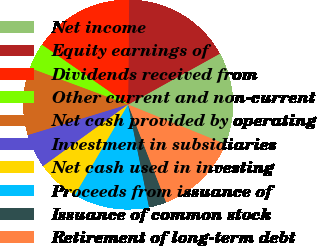Convert chart to OTSL. <chart><loc_0><loc_0><loc_500><loc_500><pie_chart><fcel>Net income<fcel>Equity earnings of<fcel>Dividends received from<fcel>Other current and non-current<fcel>Net cash provided by operating<fcel>Investment in subsidiaries<fcel>Net cash used in investing<fcel>Proceeds from issuance of<fcel>Issuance of common stock<fcel>Retirement of long-term debt<nl><fcel>14.22%<fcel>16.78%<fcel>15.5%<fcel>3.99%<fcel>10.38%<fcel>5.27%<fcel>6.55%<fcel>11.66%<fcel>2.71%<fcel>12.94%<nl></chart> 